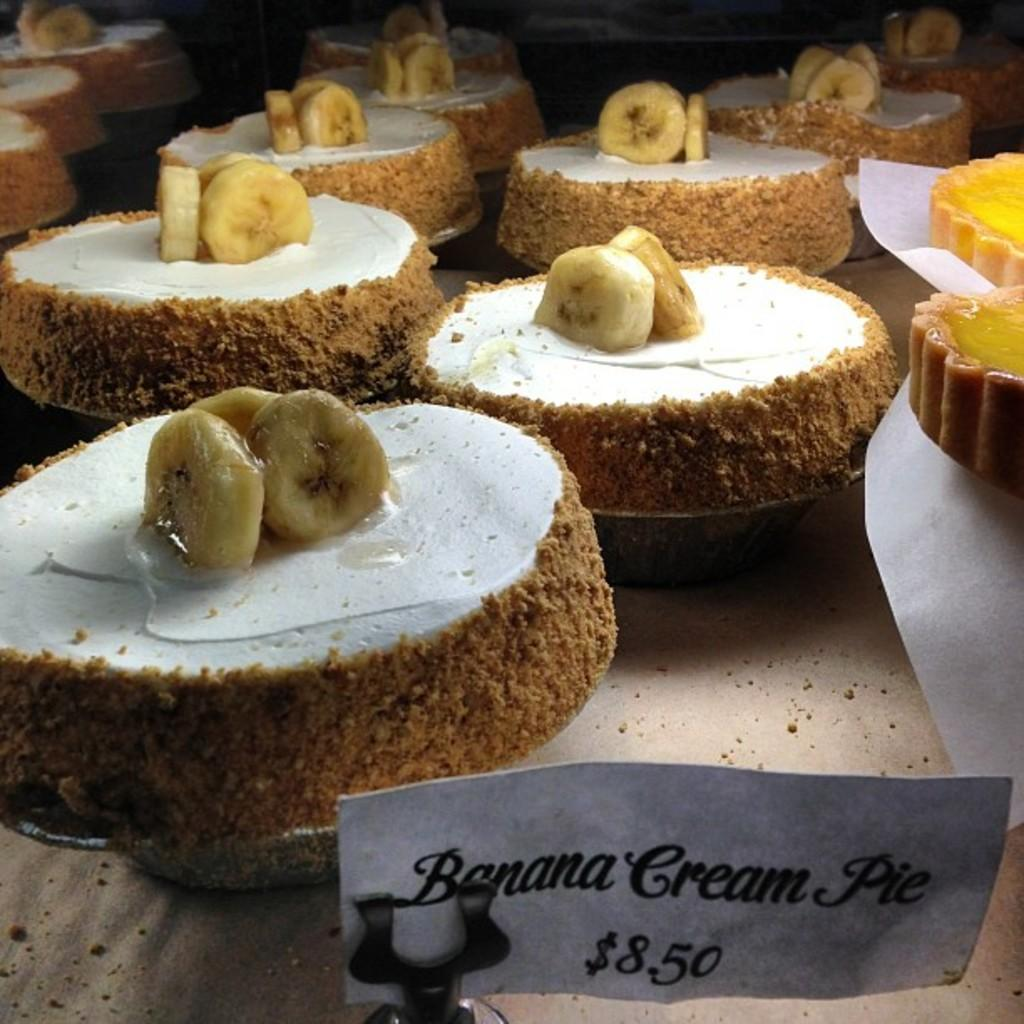What is the main subject of the image? The main subject of the image is a group of food items placed on a table. Can you describe the paper with text in the image? There is a paper with text in the foreground of the image. What type of building can be seen in the background of the image? There is no building visible in the image; it only shows a group of food items on a table and a paper with text in the foreground. 